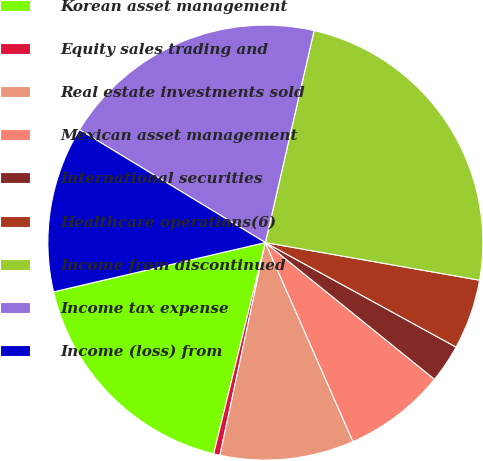<chart> <loc_0><loc_0><loc_500><loc_500><pie_chart><fcel>Korean asset management<fcel>Equity sales trading and<fcel>Real estate investments sold<fcel>Mexican asset management<fcel>International securities<fcel>Healthcare operations(6)<fcel>Income from discontinued<fcel>Income tax expense<fcel>Income (loss) from<nl><fcel>17.54%<fcel>0.47%<fcel>9.95%<fcel>7.58%<fcel>2.84%<fcel>5.21%<fcel>24.17%<fcel>19.91%<fcel>12.32%<nl></chart> 